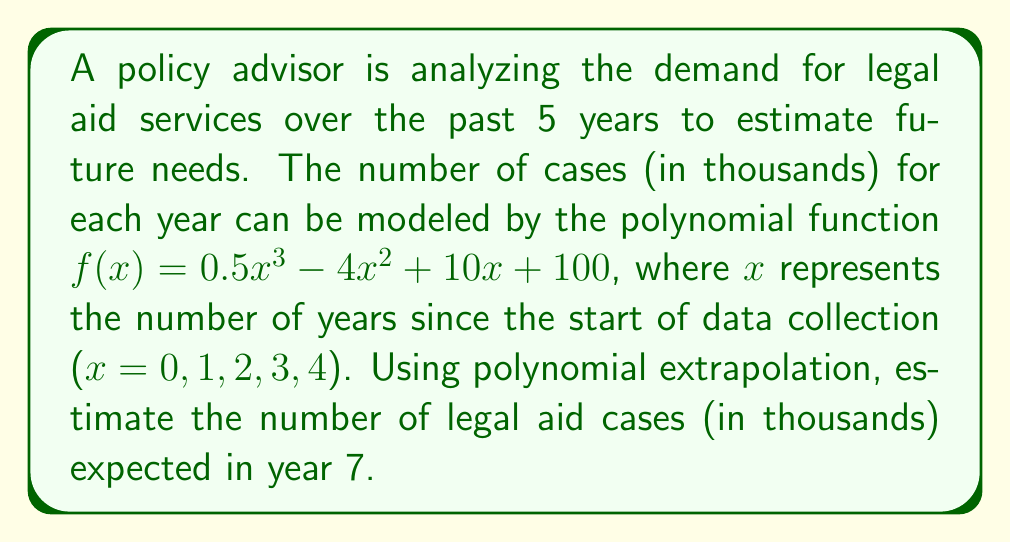What is the answer to this math problem? To estimate the number of legal aid cases in year 7 using polynomial extrapolation, we need to evaluate the given function $f(x)$ at $x = 7$. Let's break this down step-by-step:

1. Given function: $f(x) = 0.5x^3 - 4x^2 + 10x + 100$

2. Substitute $x = 7$ into the function:
   $f(7) = 0.5(7^3) - 4(7^2) + 10(7) + 100$

3. Evaluate each term:
   $0.5(7^3) = 0.5 \times 343 = 171.5$
   $4(7^2) = 4 \times 49 = 196$
   $10(7) = 70$
   $100$ remains as is

4. Combine the terms:
   $f(7) = 171.5 - 196 + 70 + 100$

5. Calculate the final result:
   $f(7) = 145.5$

Therefore, the estimated number of legal aid cases in year 7 is 145.5 thousand, or 145,500 cases.
Answer: 145,500 cases 